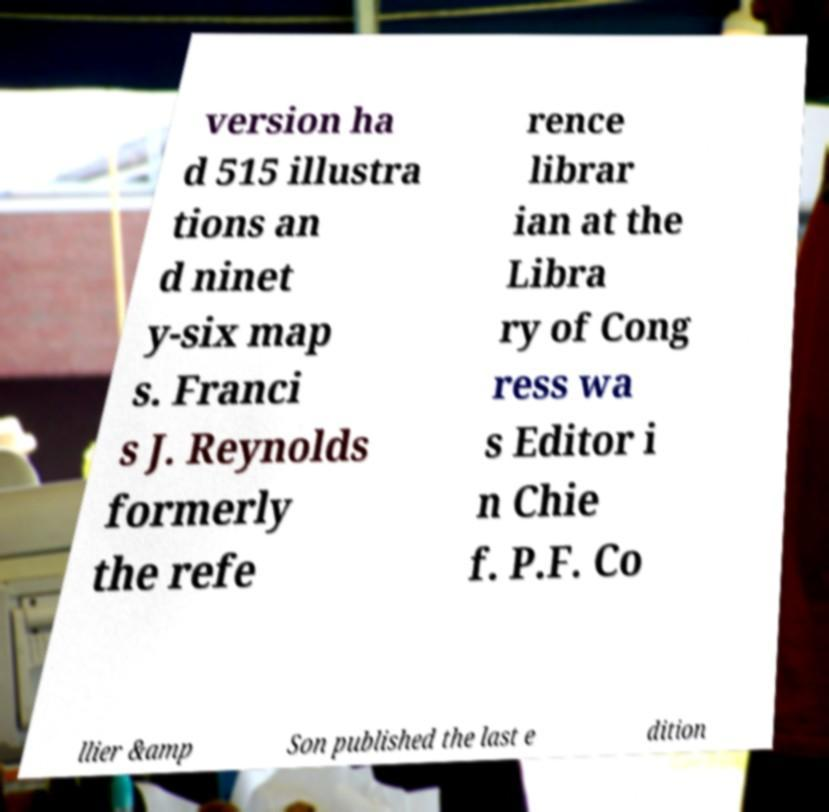I need the written content from this picture converted into text. Can you do that? version ha d 515 illustra tions an d ninet y-six map s. Franci s J. Reynolds formerly the refe rence librar ian at the Libra ry of Cong ress wa s Editor i n Chie f. P.F. Co llier &amp Son published the last e dition 